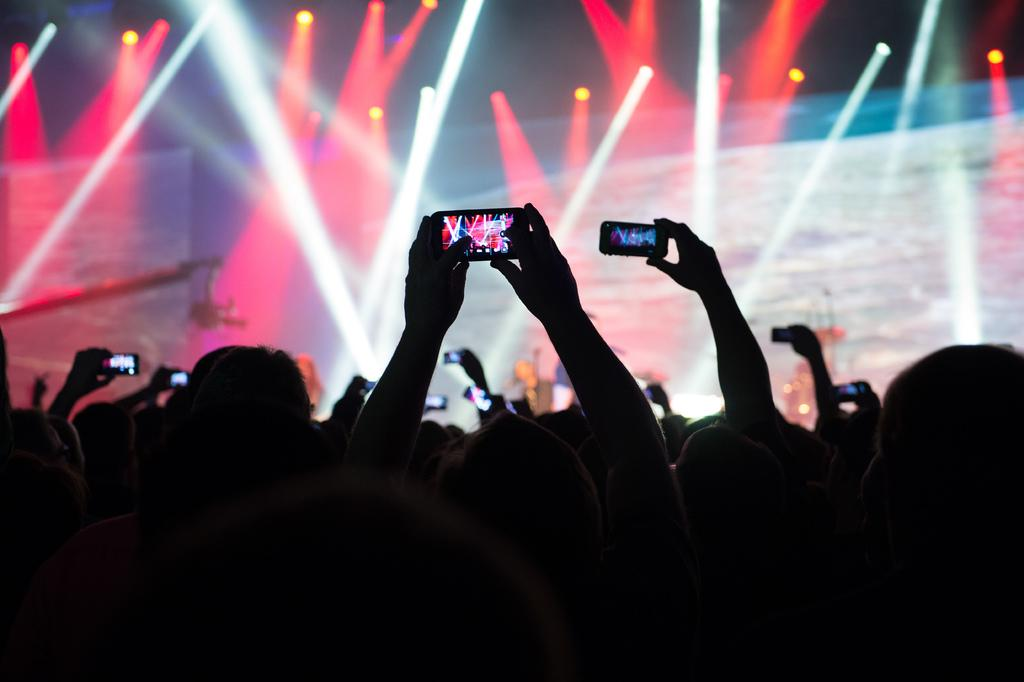What are the people in the image holding? The people in the image are holding mobiles. What type of lighting is present in the image? There are focus lights in the image. What equipment can be seen in the image? There is a crane camera in the image. Can you describe the people in the background of the image? There is a group of people in the background of the image. What type of chalk is being used to draw on the ground in the image? There is no chalk or drawing on the ground present in the image. How are the people measuring the distance between the crane camera and the focus lights in the image? There is no indication of measuring or distance being measured in the image. 